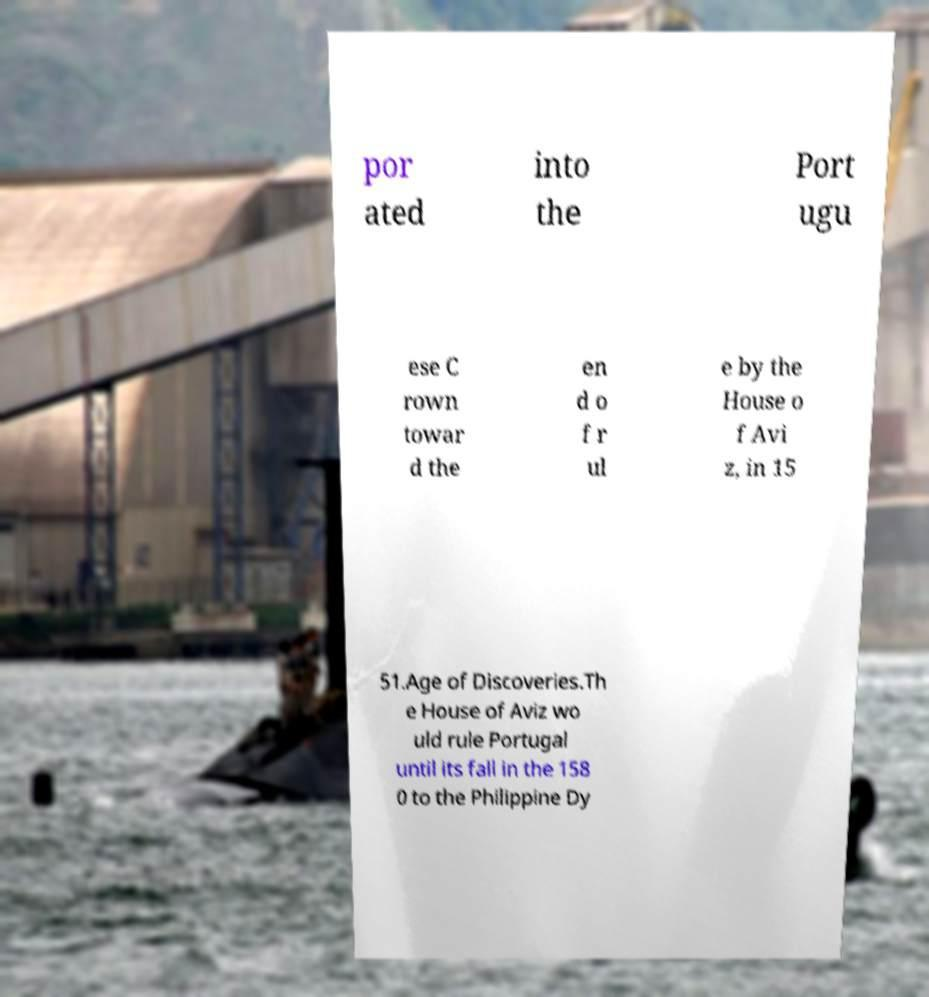There's text embedded in this image that I need extracted. Can you transcribe it verbatim? por ated into the Port ugu ese C rown towar d the en d o f r ul e by the House o f Avi z, in 15 51.Age of Discoveries.Th e House of Aviz wo uld rule Portugal until its fall in the 158 0 to the Philippine Dy 